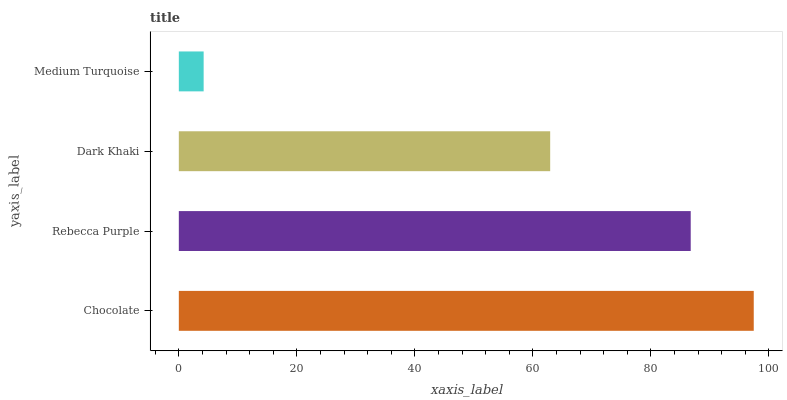Is Medium Turquoise the minimum?
Answer yes or no. Yes. Is Chocolate the maximum?
Answer yes or no. Yes. Is Rebecca Purple the minimum?
Answer yes or no. No. Is Rebecca Purple the maximum?
Answer yes or no. No. Is Chocolate greater than Rebecca Purple?
Answer yes or no. Yes. Is Rebecca Purple less than Chocolate?
Answer yes or no. Yes. Is Rebecca Purple greater than Chocolate?
Answer yes or no. No. Is Chocolate less than Rebecca Purple?
Answer yes or no. No. Is Rebecca Purple the high median?
Answer yes or no. Yes. Is Dark Khaki the low median?
Answer yes or no. Yes. Is Chocolate the high median?
Answer yes or no. No. Is Medium Turquoise the low median?
Answer yes or no. No. 